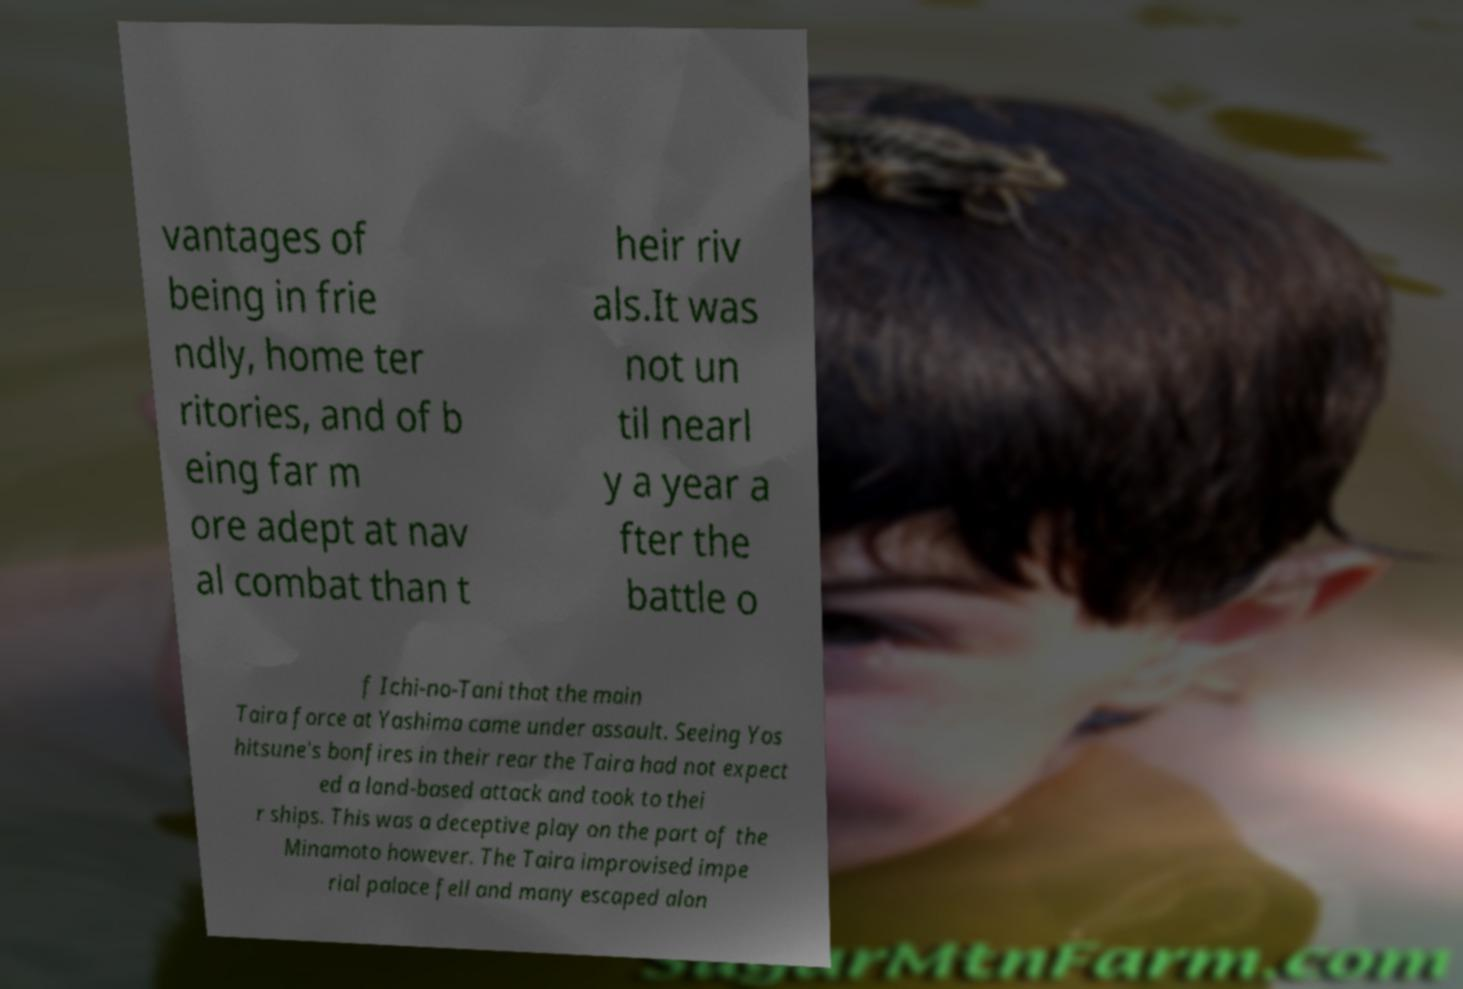I need the written content from this picture converted into text. Can you do that? vantages of being in frie ndly, home ter ritories, and of b eing far m ore adept at nav al combat than t heir riv als.It was not un til nearl y a year a fter the battle o f Ichi-no-Tani that the main Taira force at Yashima came under assault. Seeing Yos hitsune's bonfires in their rear the Taira had not expect ed a land-based attack and took to thei r ships. This was a deceptive play on the part of the Minamoto however. The Taira improvised impe rial palace fell and many escaped alon 